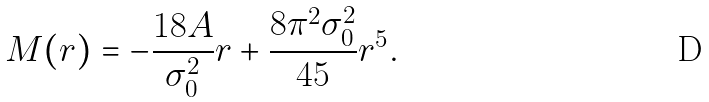Convert formula to latex. <formula><loc_0><loc_0><loc_500><loc_500>M ( r ) = - \frac { 1 8 A } { \sigma _ { 0 } ^ { 2 } } r + \frac { 8 \pi ^ { 2 } \sigma _ { 0 } ^ { 2 } } { 4 5 } r ^ { 5 } .</formula> 